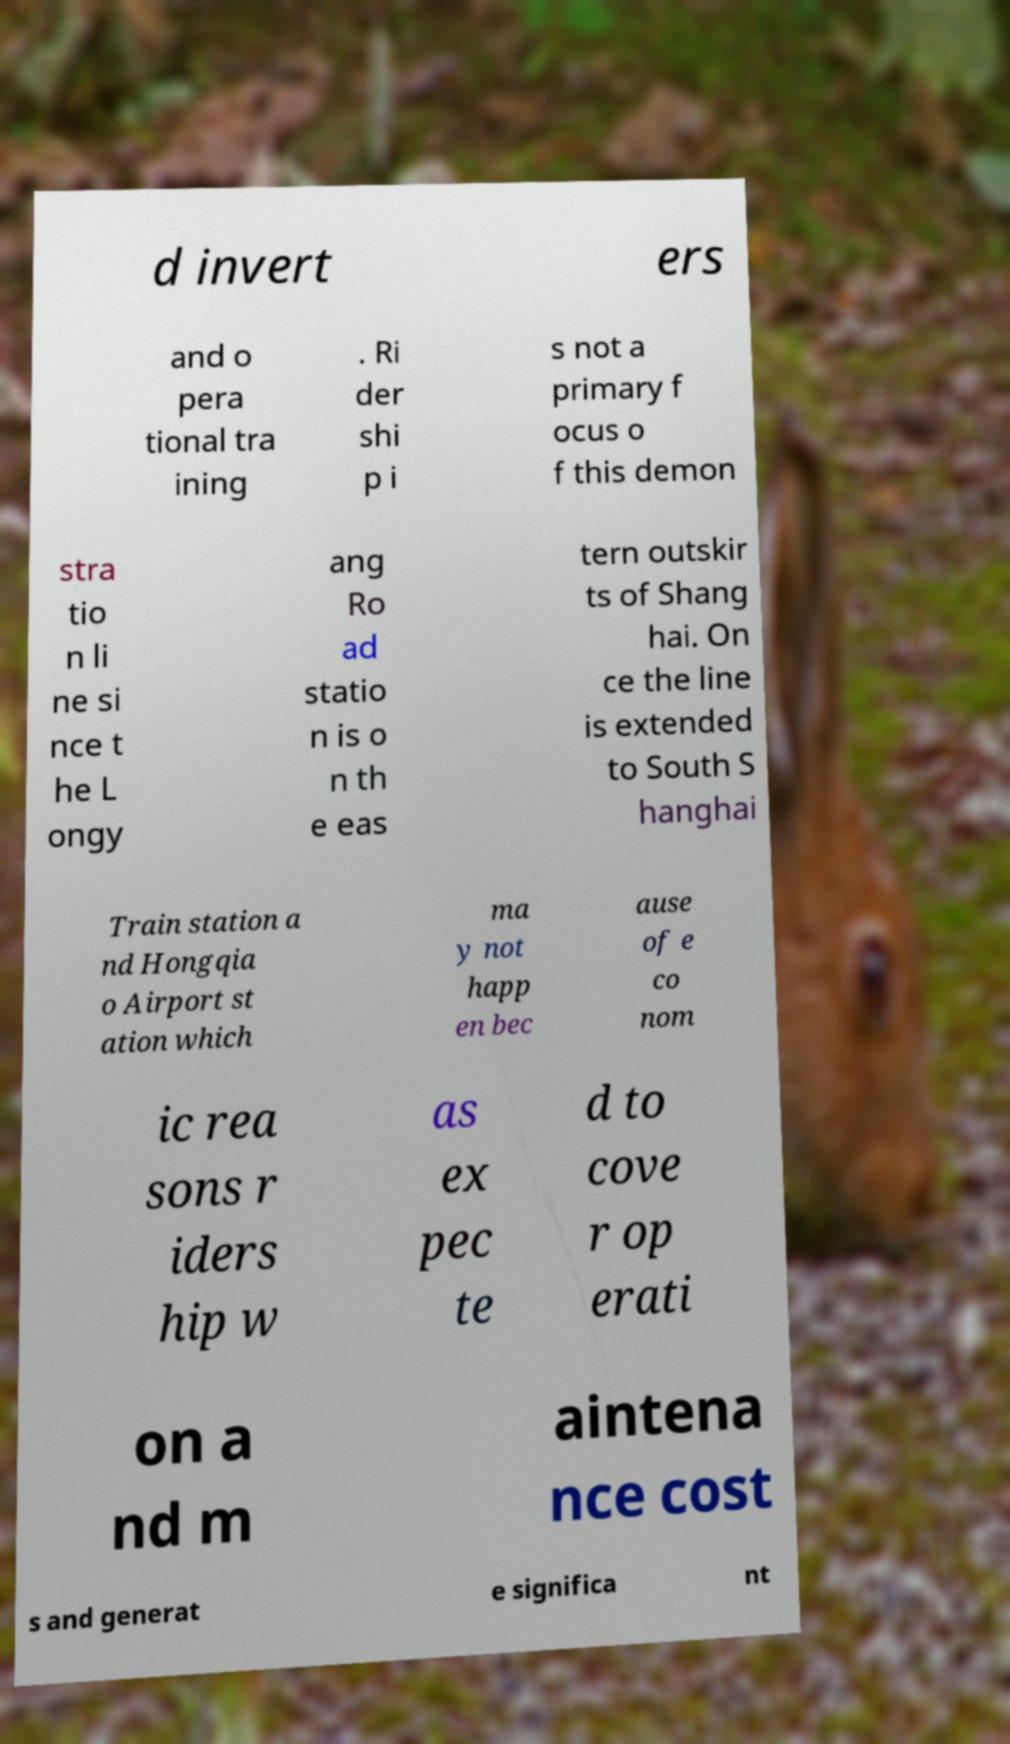Can you read and provide the text displayed in the image?This photo seems to have some interesting text. Can you extract and type it out for me? d invert ers and o pera tional tra ining . Ri der shi p i s not a primary f ocus o f this demon stra tio n li ne si nce t he L ongy ang Ro ad statio n is o n th e eas tern outskir ts of Shang hai. On ce the line is extended to South S hanghai Train station a nd Hongqia o Airport st ation which ma y not happ en bec ause of e co nom ic rea sons r iders hip w as ex pec te d to cove r op erati on a nd m aintena nce cost s and generat e significa nt 